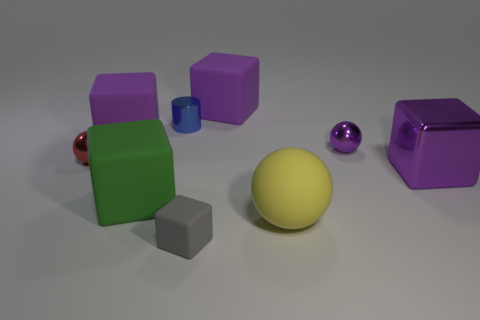Subtract all gray cylinders. How many purple cubes are left? 3 Subtract 1 cubes. How many cubes are left? 4 Subtract all green cubes. How many cubes are left? 4 Subtract all tiny cubes. How many cubes are left? 4 Subtract all gray balls. Subtract all green cubes. How many balls are left? 3 Add 1 purple matte things. How many objects exist? 10 Subtract all cylinders. How many objects are left? 8 Add 7 metal cubes. How many metal cubes are left? 8 Add 1 large yellow rubber balls. How many large yellow rubber balls exist? 2 Subtract 1 purple balls. How many objects are left? 8 